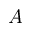<formula> <loc_0><loc_0><loc_500><loc_500>A</formula> 